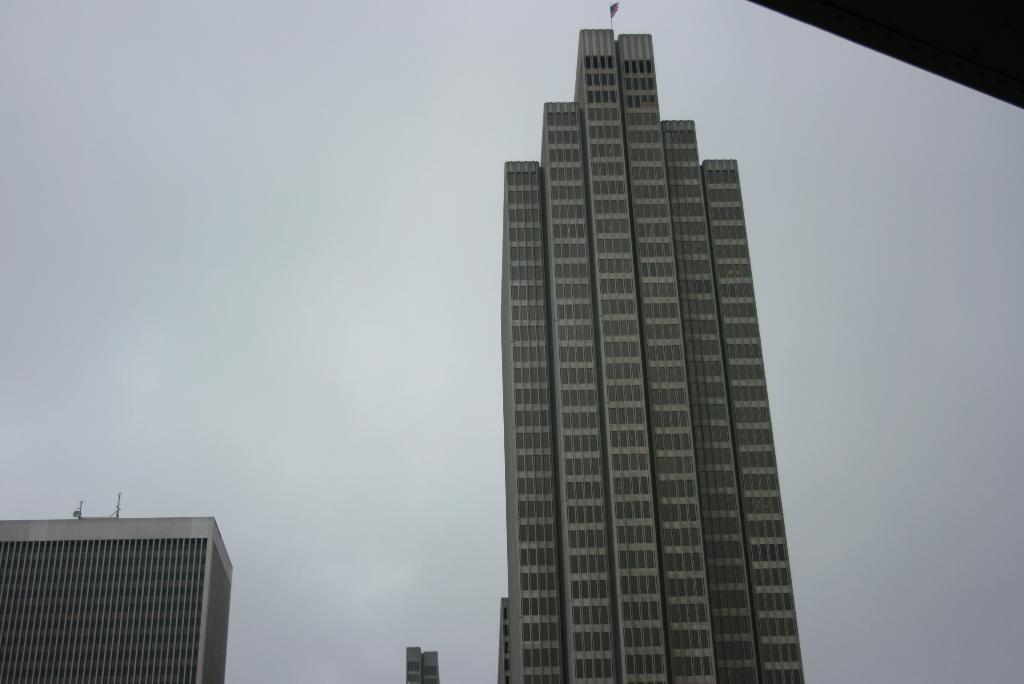What type of structures can be seen in the image? There are buildings in the image. Is there any symbol or emblem visible in the image? Yes, there is a flag in the image. Can you describe any specific details about the building on the right side of the image? There are objects on the building at the right side of the image. How many bridges can be seen connecting the buildings in the image? There are no bridges visible in the image; it only shows buildings and a flag. What type of respect is being shown by the buildings in the image? Buildings do not have the ability to show respect, as they are inanimate structures. 